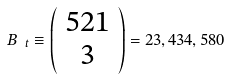<formula> <loc_0><loc_0><loc_500><loc_500>B _ { \ t } \equiv \left ( \begin{array} { c } 5 2 1 \\ 3 \end{array} \right ) = 2 3 , 4 3 4 , 5 8 0</formula> 